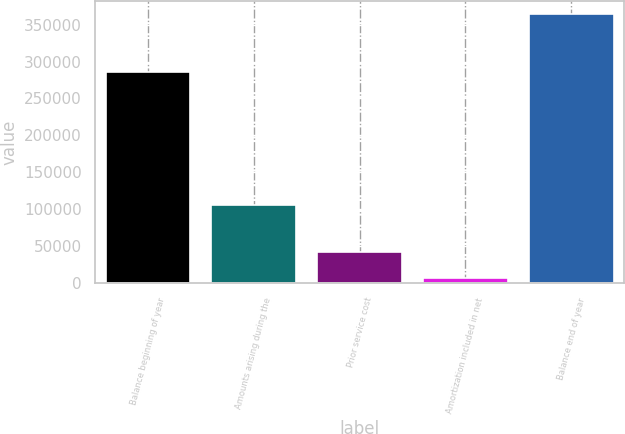Convert chart. <chart><loc_0><loc_0><loc_500><loc_500><bar_chart><fcel>Balance beginning of year<fcel>Amounts arising during the<fcel>Prior service cost<fcel>Amortization included in net<fcel>Balance end of year<nl><fcel>285177<fcel>105527<fcel>42547.6<fcel>6865<fcel>363691<nl></chart> 